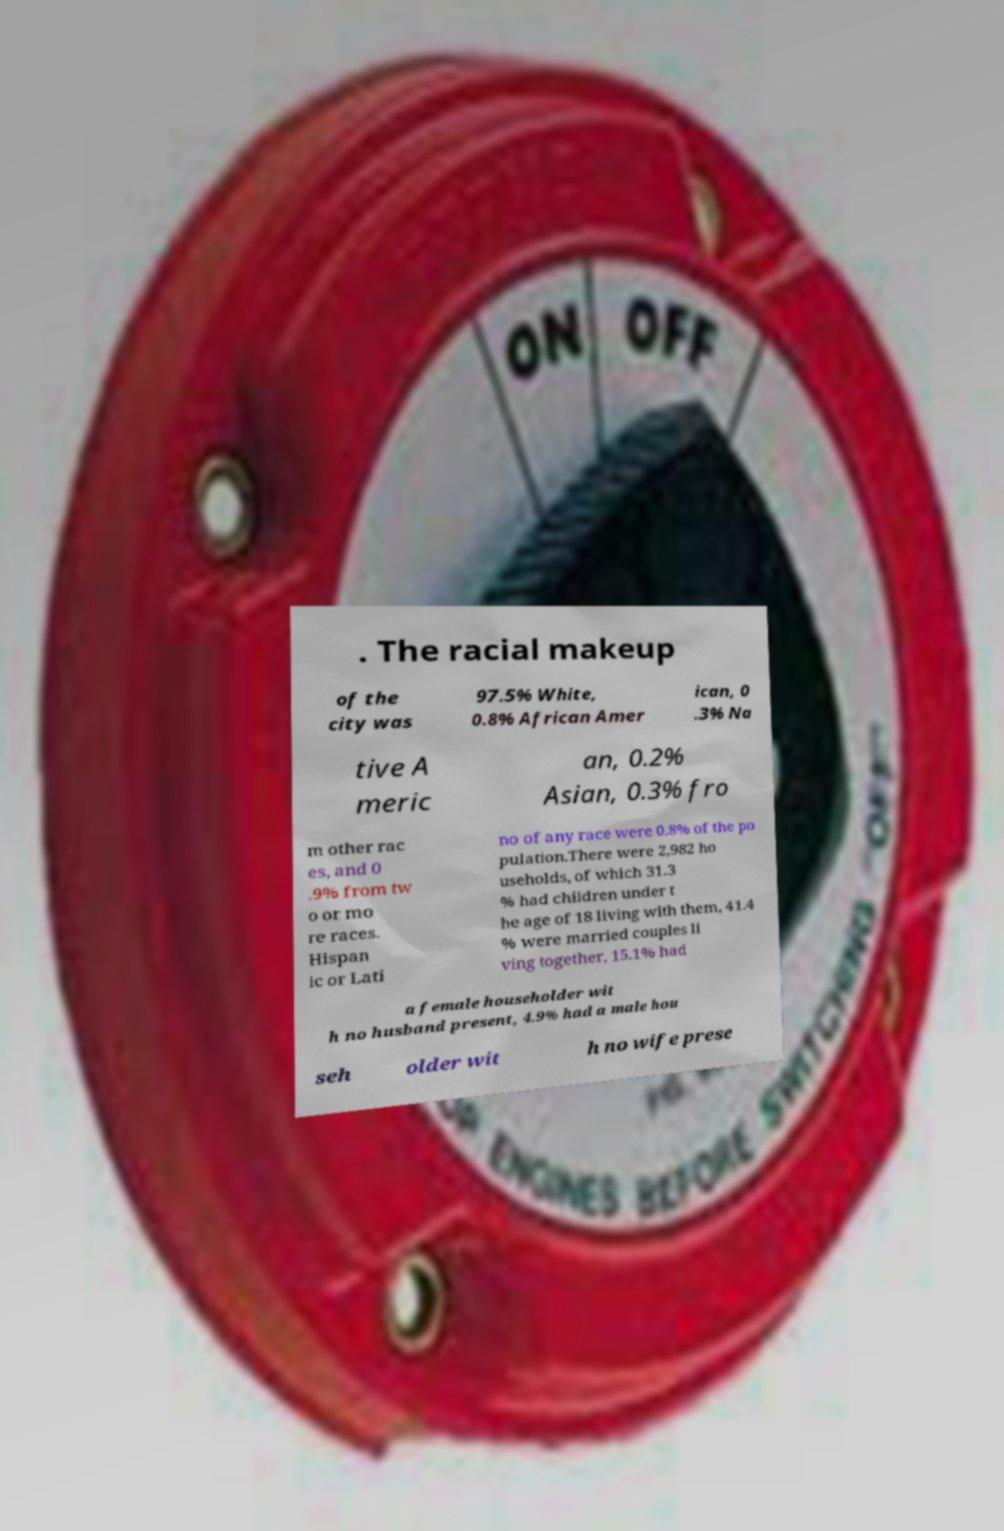There's text embedded in this image that I need extracted. Can you transcribe it verbatim? . The racial makeup of the city was 97.5% White, 0.8% African Amer ican, 0 .3% Na tive A meric an, 0.2% Asian, 0.3% fro m other rac es, and 0 .9% from tw o or mo re races. Hispan ic or Lati no of any race were 0.8% of the po pulation.There were 2,982 ho useholds, of which 31.3 % had children under t he age of 18 living with them, 41.4 % were married couples li ving together, 15.1% had a female householder wit h no husband present, 4.9% had a male hou seh older wit h no wife prese 